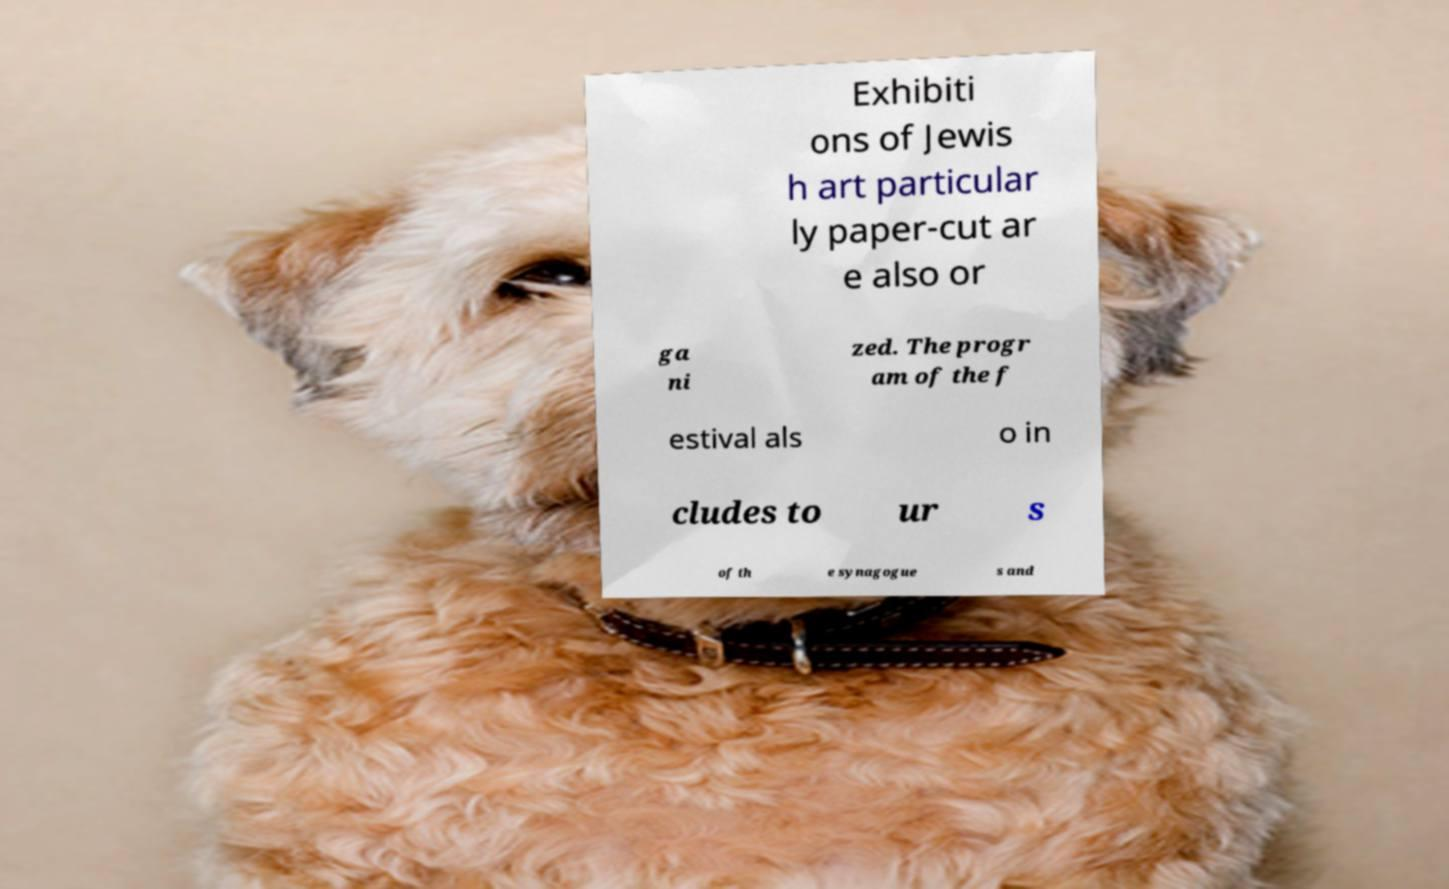Can you read and provide the text displayed in the image?This photo seems to have some interesting text. Can you extract and type it out for me? Exhibiti ons of Jewis h art particular ly paper-cut ar e also or ga ni zed. The progr am of the f estival als o in cludes to ur s of th e synagogue s and 